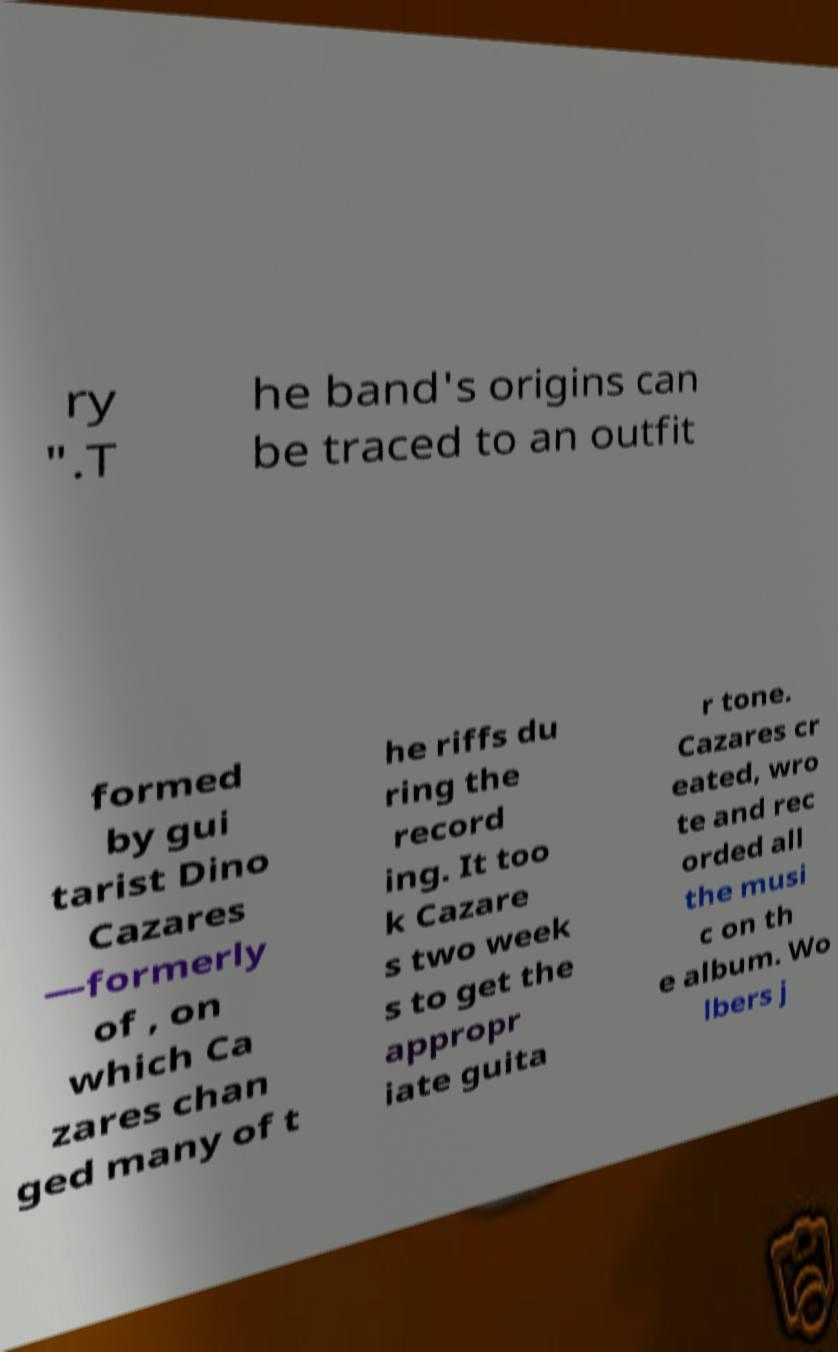There's text embedded in this image that I need extracted. Can you transcribe it verbatim? ry ".T he band's origins can be traced to an outfit formed by gui tarist Dino Cazares —formerly of , on which Ca zares chan ged many of t he riffs du ring the record ing. It too k Cazare s two week s to get the appropr iate guita r tone. Cazares cr eated, wro te and rec orded all the musi c on th e album. Wo lbers j 